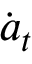Convert formula to latex. <formula><loc_0><loc_0><loc_500><loc_500>\dot { a } _ { t }</formula> 